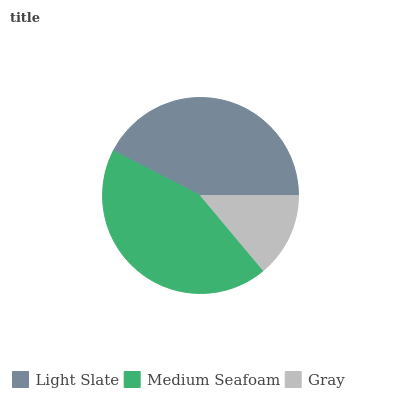Is Gray the minimum?
Answer yes or no. Yes. Is Medium Seafoam the maximum?
Answer yes or no. Yes. Is Medium Seafoam the minimum?
Answer yes or no. No. Is Gray the maximum?
Answer yes or no. No. Is Medium Seafoam greater than Gray?
Answer yes or no. Yes. Is Gray less than Medium Seafoam?
Answer yes or no. Yes. Is Gray greater than Medium Seafoam?
Answer yes or no. No. Is Medium Seafoam less than Gray?
Answer yes or no. No. Is Light Slate the high median?
Answer yes or no. Yes. Is Light Slate the low median?
Answer yes or no. Yes. Is Gray the high median?
Answer yes or no. No. Is Gray the low median?
Answer yes or no. No. 